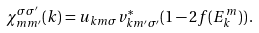Convert formula to latex. <formula><loc_0><loc_0><loc_500><loc_500>\chi _ { m m ^ { \prime } } ^ { \sigma \sigma ^ { \prime } } ( { k } ) = u _ { { k } m \sigma } v ^ { * } _ { { k } m ^ { \prime } \sigma ^ { \prime } } ( 1 - 2 f ( E _ { k } ^ { m } ) ) \, .</formula> 